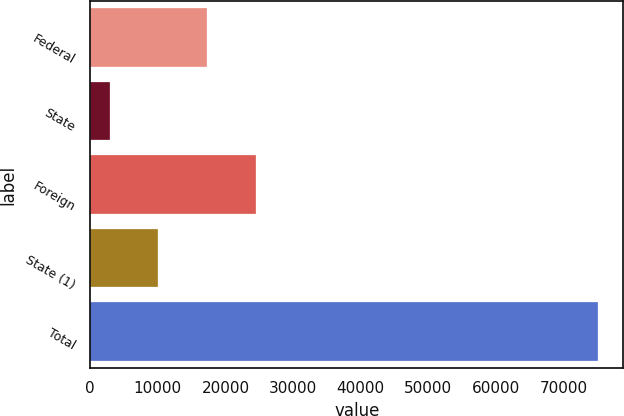<chart> <loc_0><loc_0><loc_500><loc_500><bar_chart><fcel>Federal<fcel>State<fcel>Foreign<fcel>State (1)<fcel>Total<nl><fcel>17309.2<fcel>2871<fcel>24528.3<fcel>10090.1<fcel>75062<nl></chart> 